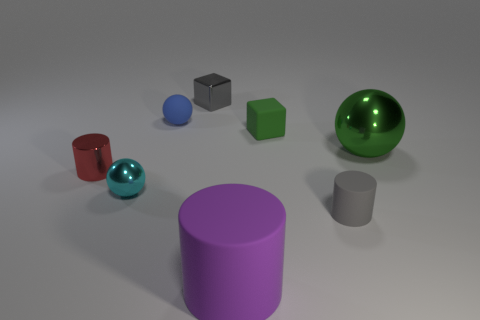Add 1 small metallic things. How many objects exist? 9 Subtract all cubes. How many objects are left? 6 Subtract all large red matte objects. Subtract all small gray cubes. How many objects are left? 7 Add 2 gray matte cylinders. How many gray matte cylinders are left? 3 Add 7 small blue rubber cylinders. How many small blue rubber cylinders exist? 7 Subtract 0 red spheres. How many objects are left? 8 